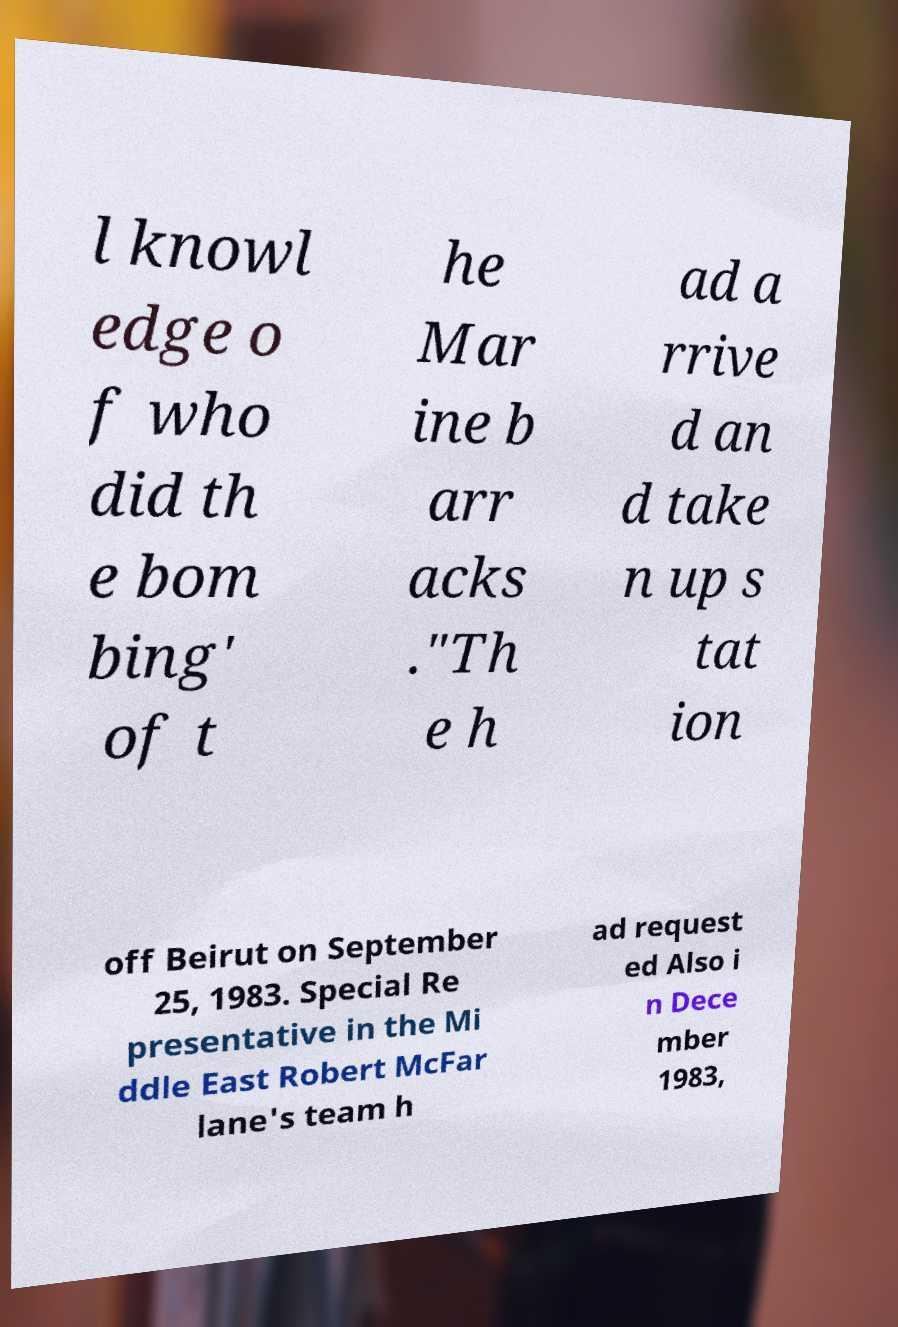Could you extract and type out the text from this image? l knowl edge o f who did th e bom bing' of t he Mar ine b arr acks ."Th e h ad a rrive d an d take n up s tat ion off Beirut on September 25, 1983. Special Re presentative in the Mi ddle East Robert McFar lane's team h ad request ed Also i n Dece mber 1983, 